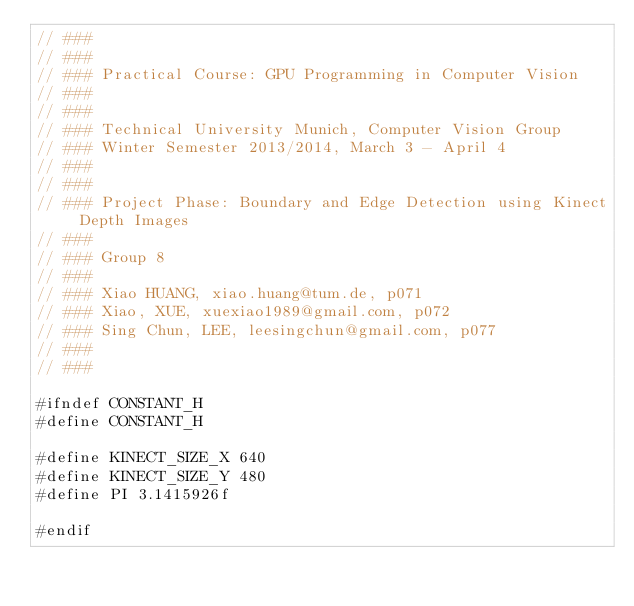<code> <loc_0><loc_0><loc_500><loc_500><_Cuda_>// ###
// ###
// ### Practical Course: GPU Programming in Computer Vision
// ### 
// ###
// ### Technical University Munich, Computer Vision Group
// ### Winter Semester 2013/2014, March 3 - April 4
// ###
// ###
// ### Project Phase: Boundary and Edge Detection using Kinect Depth Images
// ###
// ### Group 8
// ### 
// ### Xiao HUANG, xiao.huang@tum.de, p071
// ### Xiao, XUE, xuexiao1989@gmail.com, p072
// ### Sing Chun, LEE, leesingchun@gmail.com, p077
// ###
// ###

#ifndef CONSTANT_H
#define CONSTANT_H

#define KINECT_SIZE_X 640
#define KINECT_SIZE_Y 480
#define PI 3.1415926f

#endif
</code> 